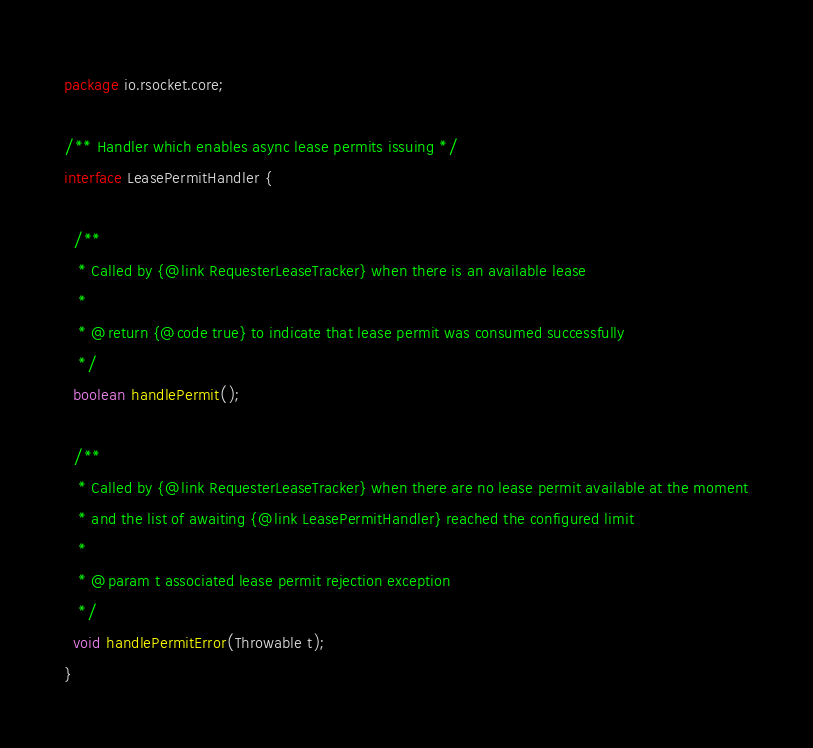Convert code to text. <code><loc_0><loc_0><loc_500><loc_500><_Java_>package io.rsocket.core;

/** Handler which enables async lease permits issuing */
interface LeasePermitHandler {

  /**
   * Called by {@link RequesterLeaseTracker} when there is an available lease
   *
   * @return {@code true} to indicate that lease permit was consumed successfully
   */
  boolean handlePermit();

  /**
   * Called by {@link RequesterLeaseTracker} when there are no lease permit available at the moment
   * and the list of awaiting {@link LeasePermitHandler} reached the configured limit
   *
   * @param t associated lease permit rejection exception
   */
  void handlePermitError(Throwable t);
}
</code> 